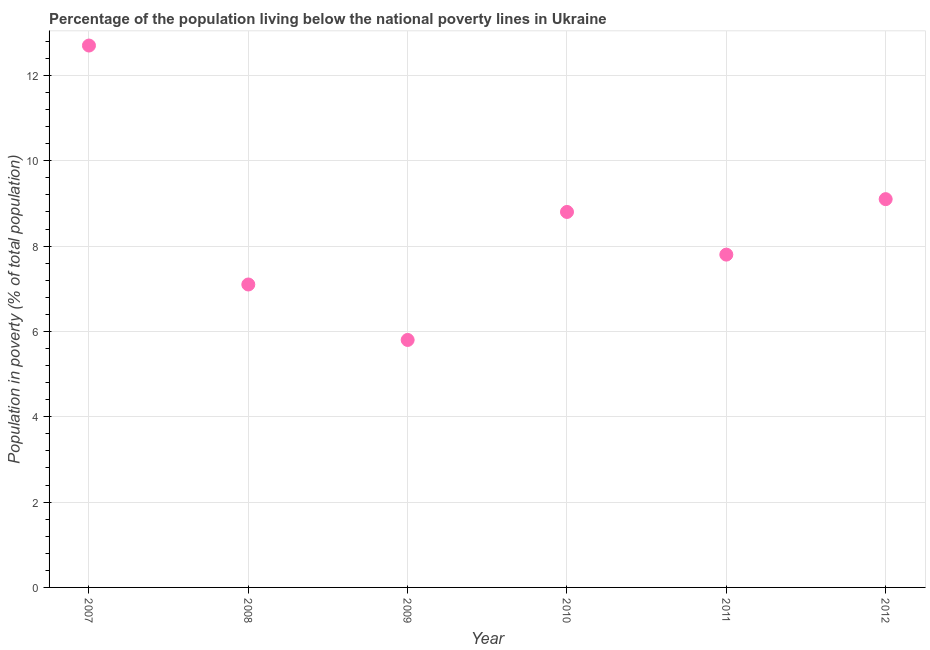Across all years, what is the maximum percentage of population living below poverty line?
Your answer should be compact. 12.7. Across all years, what is the minimum percentage of population living below poverty line?
Offer a terse response. 5.8. What is the sum of the percentage of population living below poverty line?
Offer a terse response. 51.3. What is the difference between the percentage of population living below poverty line in 2010 and 2012?
Keep it short and to the point. -0.3. What is the average percentage of population living below poverty line per year?
Your response must be concise. 8.55. What is the median percentage of population living below poverty line?
Offer a very short reply. 8.3. In how many years, is the percentage of population living below poverty line greater than 9.6 %?
Provide a succinct answer. 1. Do a majority of the years between 2009 and 2007 (inclusive) have percentage of population living below poverty line greater than 12.4 %?
Make the answer very short. No. What is the ratio of the percentage of population living below poverty line in 2010 to that in 2011?
Keep it short and to the point. 1.13. Is the percentage of population living below poverty line in 2011 less than that in 2012?
Offer a terse response. Yes. Is the difference between the percentage of population living below poverty line in 2008 and 2009 greater than the difference between any two years?
Your answer should be very brief. No. What is the difference between the highest and the second highest percentage of population living below poverty line?
Your answer should be compact. 3.6. Is the sum of the percentage of population living below poverty line in 2008 and 2011 greater than the maximum percentage of population living below poverty line across all years?
Provide a short and direct response. Yes. What is the difference between the highest and the lowest percentage of population living below poverty line?
Your response must be concise. 6.9. In how many years, is the percentage of population living below poverty line greater than the average percentage of population living below poverty line taken over all years?
Offer a very short reply. 3. How many dotlines are there?
Provide a short and direct response. 1. How many years are there in the graph?
Give a very brief answer. 6. What is the difference between two consecutive major ticks on the Y-axis?
Your answer should be compact. 2. Does the graph contain any zero values?
Provide a short and direct response. No. What is the title of the graph?
Give a very brief answer. Percentage of the population living below the national poverty lines in Ukraine. What is the label or title of the X-axis?
Ensure brevity in your answer.  Year. What is the label or title of the Y-axis?
Keep it short and to the point. Population in poverty (% of total population). What is the Population in poverty (% of total population) in 2010?
Provide a short and direct response. 8.8. What is the Population in poverty (% of total population) in 2011?
Provide a short and direct response. 7.8. What is the difference between the Population in poverty (% of total population) in 2007 and 2009?
Provide a short and direct response. 6.9. What is the difference between the Population in poverty (% of total population) in 2007 and 2010?
Ensure brevity in your answer.  3.9. What is the difference between the Population in poverty (% of total population) in 2007 and 2011?
Provide a short and direct response. 4.9. What is the difference between the Population in poverty (% of total population) in 2008 and 2009?
Make the answer very short. 1.3. What is the difference between the Population in poverty (% of total population) in 2009 and 2010?
Your response must be concise. -3. What is the difference between the Population in poverty (% of total population) in 2009 and 2011?
Give a very brief answer. -2. What is the difference between the Population in poverty (% of total population) in 2009 and 2012?
Provide a short and direct response. -3.3. What is the difference between the Population in poverty (% of total population) in 2010 and 2012?
Your answer should be compact. -0.3. What is the difference between the Population in poverty (% of total population) in 2011 and 2012?
Give a very brief answer. -1.3. What is the ratio of the Population in poverty (% of total population) in 2007 to that in 2008?
Provide a short and direct response. 1.79. What is the ratio of the Population in poverty (% of total population) in 2007 to that in 2009?
Your answer should be compact. 2.19. What is the ratio of the Population in poverty (% of total population) in 2007 to that in 2010?
Offer a terse response. 1.44. What is the ratio of the Population in poverty (% of total population) in 2007 to that in 2011?
Provide a succinct answer. 1.63. What is the ratio of the Population in poverty (% of total population) in 2007 to that in 2012?
Give a very brief answer. 1.4. What is the ratio of the Population in poverty (% of total population) in 2008 to that in 2009?
Keep it short and to the point. 1.22. What is the ratio of the Population in poverty (% of total population) in 2008 to that in 2010?
Offer a very short reply. 0.81. What is the ratio of the Population in poverty (% of total population) in 2008 to that in 2011?
Give a very brief answer. 0.91. What is the ratio of the Population in poverty (% of total population) in 2008 to that in 2012?
Your response must be concise. 0.78. What is the ratio of the Population in poverty (% of total population) in 2009 to that in 2010?
Your response must be concise. 0.66. What is the ratio of the Population in poverty (% of total population) in 2009 to that in 2011?
Your answer should be compact. 0.74. What is the ratio of the Population in poverty (% of total population) in 2009 to that in 2012?
Offer a very short reply. 0.64. What is the ratio of the Population in poverty (% of total population) in 2010 to that in 2011?
Provide a succinct answer. 1.13. What is the ratio of the Population in poverty (% of total population) in 2011 to that in 2012?
Provide a succinct answer. 0.86. 